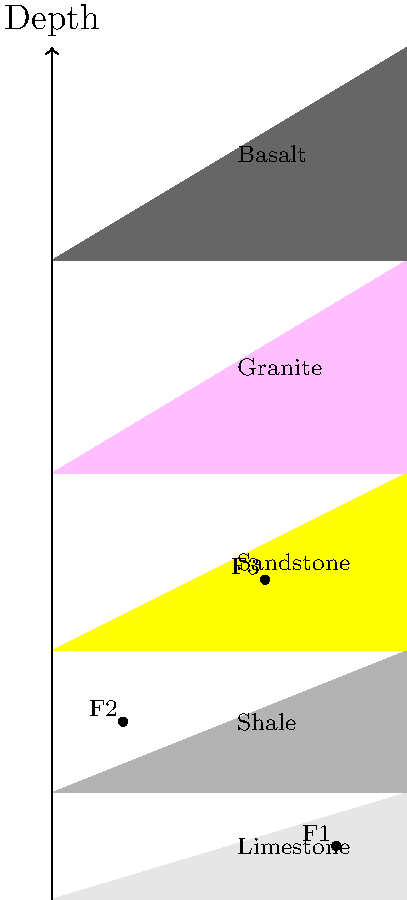Based on the stratigraphic column shown, which of the following statements is correct regarding the relative ages of the rock layers and fossils?

A) Fossil F1 is older than the granite layer
B) The basalt layer is the youngest
C) Fossil F3 is older than fossil F2
D) The limestone layer is the oldest sedimentary rock To determine the relative ages of rock layers and fossils, we use the principles of superposition and fossil succession. Let's analyze the stratigraphic column step by step:

1. Principle of Superposition: In undisturbed sedimentary sequences, younger layers are deposited on top of older layers. 

2. Starting from the bottom:
   - Basalt (igneous rock)
   - Granite (igneous rock)
   - Sandstone (sedimentary rock)
   - Shale (sedimentary rock)
   - Limestone (sedimentary rock)

3. Among the sedimentary rocks, limestone is the youngest, and sandstone is the oldest.

4. Fossil positions:
   - F3 is in the sandstone layer
   - F2 is in the shale layer
   - F1 is in the limestone layer

5. Fossil succession: Younger fossils are found in more recent layers.

6. The granite and basalt layers are igneous rocks, which could be intrusive or extrusive. Their relative age to the sedimentary layers depends on when they formed.

Analyzing the given options:
A) Fossil F1 is in the limestone layer, which is above (younger than) the granite layer.
B) The basalt layer is at the bottom, making it the oldest visible layer.
C) Fossil F3 is in an older layer (sandstone) compared to F2 (shale), so F3 is older than F2.
D) The limestone layer is the youngest sedimentary rock in the column.

Therefore, the correct statement is C: Fossil F3 is older than fossil F2.
Answer: C 